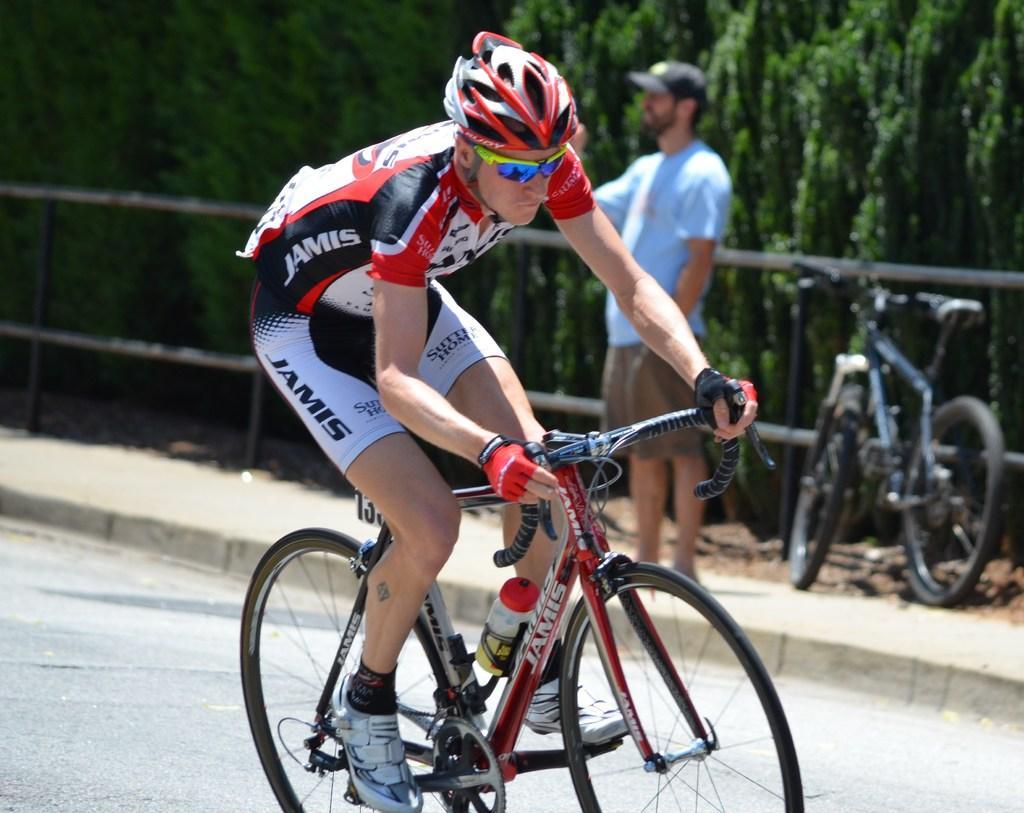Describe this image in one or two sentences. In this image there is a person riding a bicycle on the road, behind him there is another person standing on the path and there is a bicycle, behind the bicycle there is a railing. In the background there are trees. 